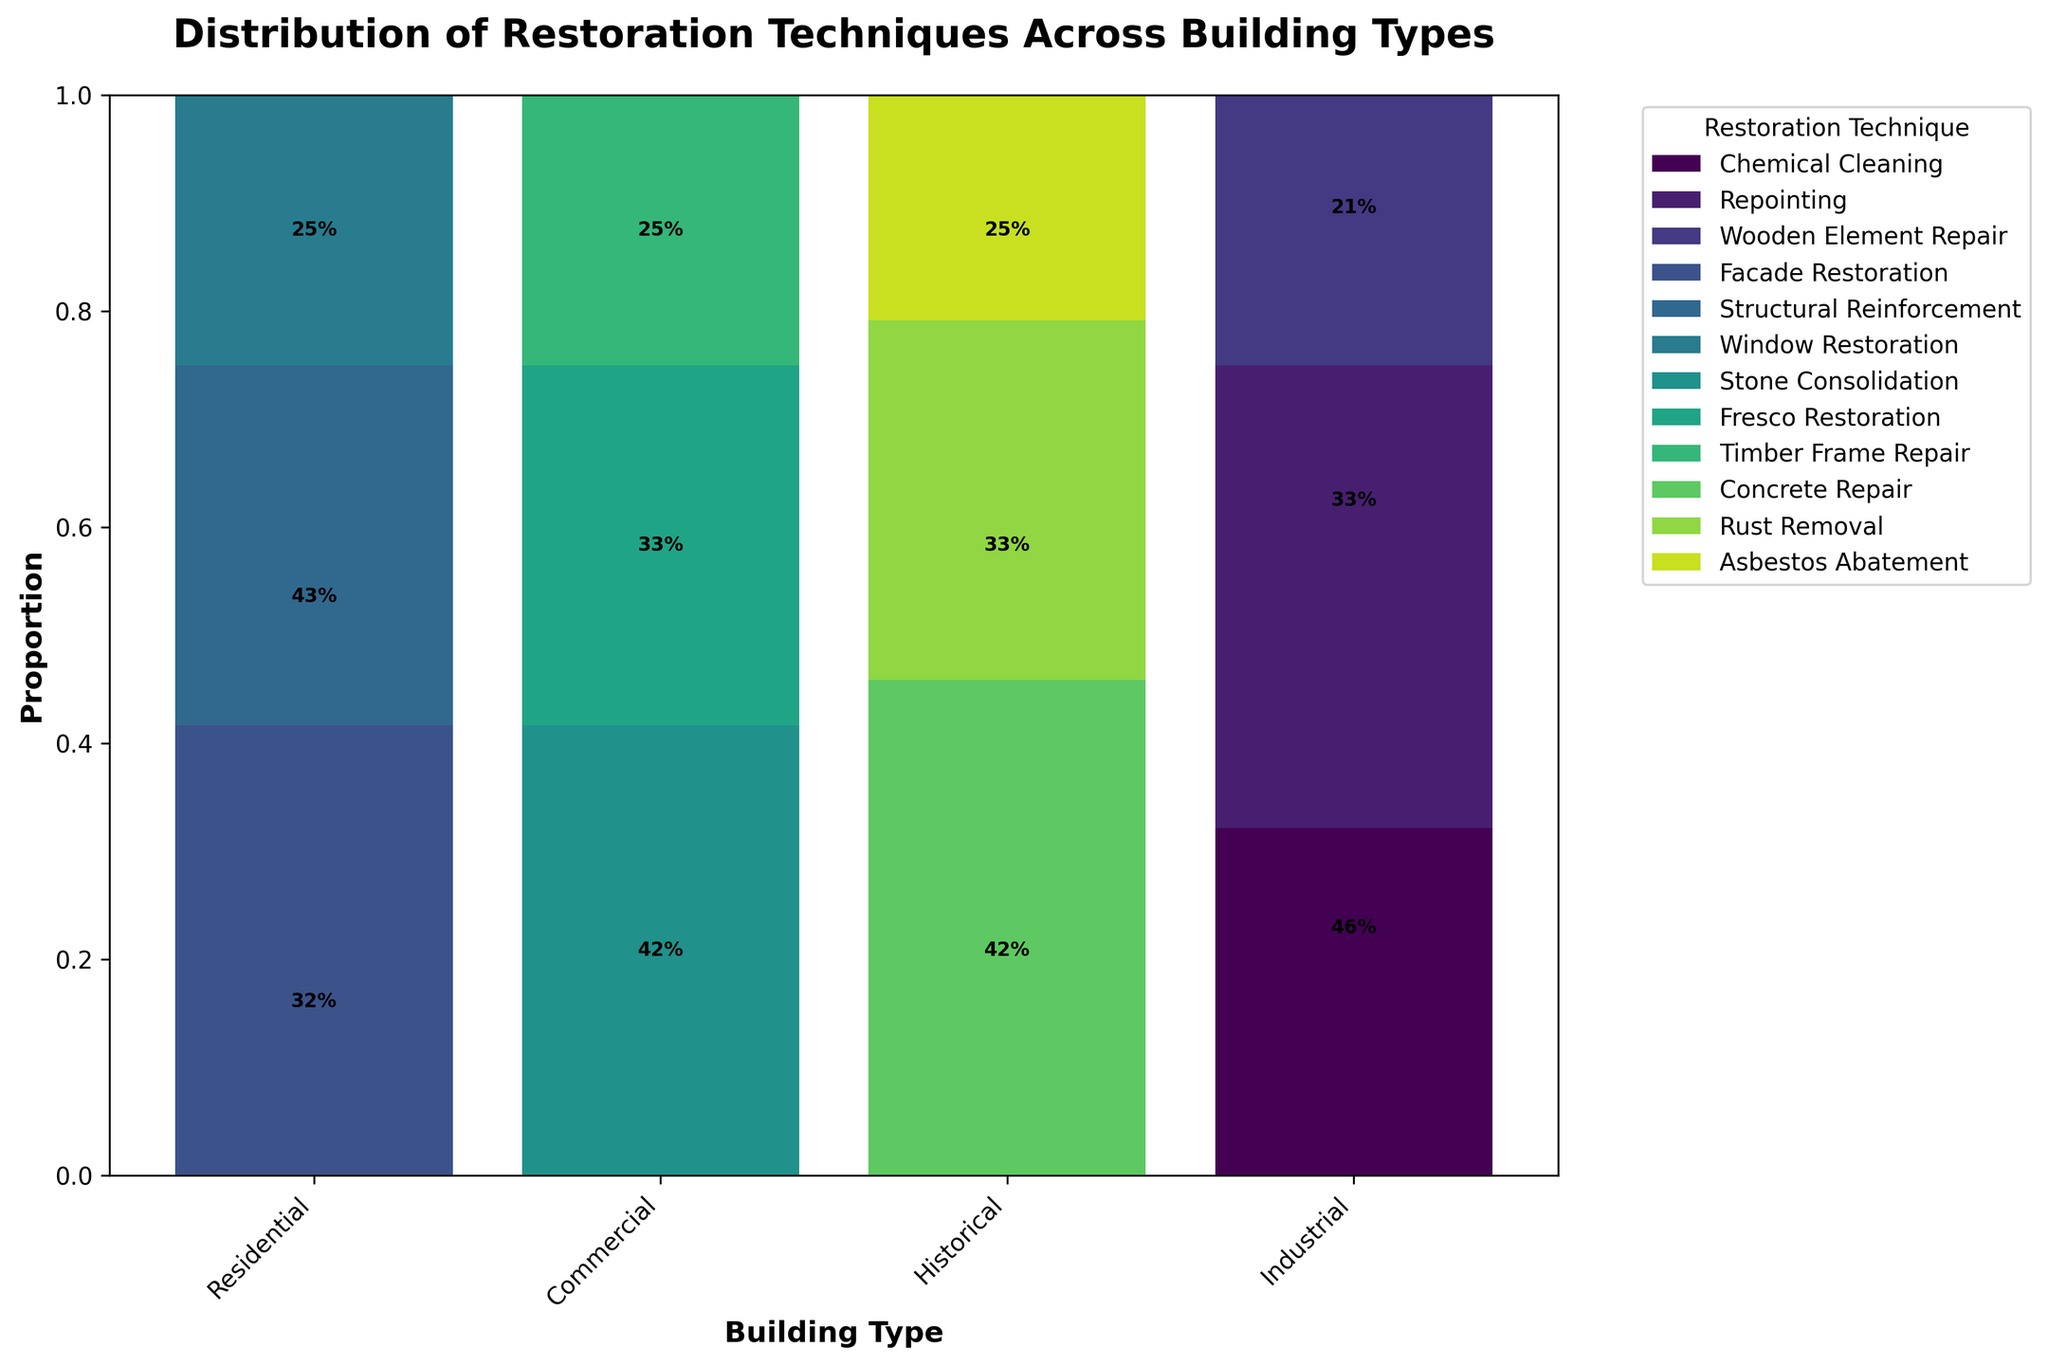What is the title of the plot? The title is generally located at the top of the plot. In this case, the title reads "Distribution of Restoration Techniques Across Building Types."
Answer: Distribution of Restoration Techniques Across Building Types Which building type has the highest proportion of "Chemical Cleaning"? To find this, look for the segment labeled "Chemical Cleaning" and identify the building type with the largest segment in proportion. Residential has the highest proportion.
Answer: Residential What is the total proportion of "Structural Reinforcement" and "Window Restoration" for Commercial buildings? First, locate the two segments for "Structural Reinforcement" and "Window Restoration" under Commercial buildings. Then sum their proportions. This is roughly 40% (Structural Reinforcement) + 30% (Window Restoration) = 70%.
Answer: 70% Which restoration technique is most frequently used across all building types? By observing the heights of the bars from each restoration technique across all building types, "Repointing" in Residential appears to have the highest single proportion.
Answer: Repointing How does the proportion of "Concrete Repair" in Industrial compare to "Facade Restoration" in Commercial? Find the proportional heights of both segments in their respective building types. "Concrete Repair" in Industrial is roughly more than "Facade Restoration" in Commercial.
Answer: Concrete Repair has a higher proportion What is the least utilized technique in Historical buildings? For Historical buildings, find the smallest proportion segment amongst all techniques. "Timber Frame Repair" has the smallest proportion.
Answer: Timber Frame Repair What restoration technique is not used at all in Industrial buildings? Look at the segments for Industrial buildings and identify the techniques with zero proportions. Techniques like "Fresco Restoration" and "Timber Frame Repair" are not used.
Answer: Fresco Restoration and Timber Frame Repair Which building type uses the widest variety of restoration techniques? Observe which building type has the most diverse segments. Both Residential and Commercial seem to show a wide variety of techniques.
Answer: Residential and Commercial How is the use of "Facade Restoration" distributed across different building types? Look at the segments belonging to "Facade Restoration" in each building type. It is only present in Commercial buildings.
Answer: Only in Commercial What percentage of Residential restoration uses "Wooden Element Repair"? Locate the segment for "Wooden Element Repair" in Residential and read the percentage label or estimate from its height. The proportion is roughly 35%.
Answer: 35% 